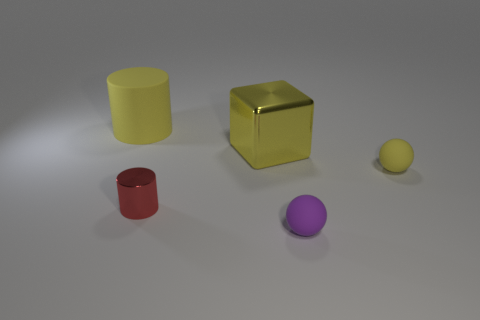Add 3 metal cubes. How many objects exist? 8 Subtract all cylinders. How many objects are left? 3 Subtract 0 gray blocks. How many objects are left? 5 Subtract all tiny purple balls. Subtract all matte cylinders. How many objects are left? 3 Add 1 small yellow spheres. How many small yellow spheres are left? 2 Add 2 large yellow cubes. How many large yellow cubes exist? 3 